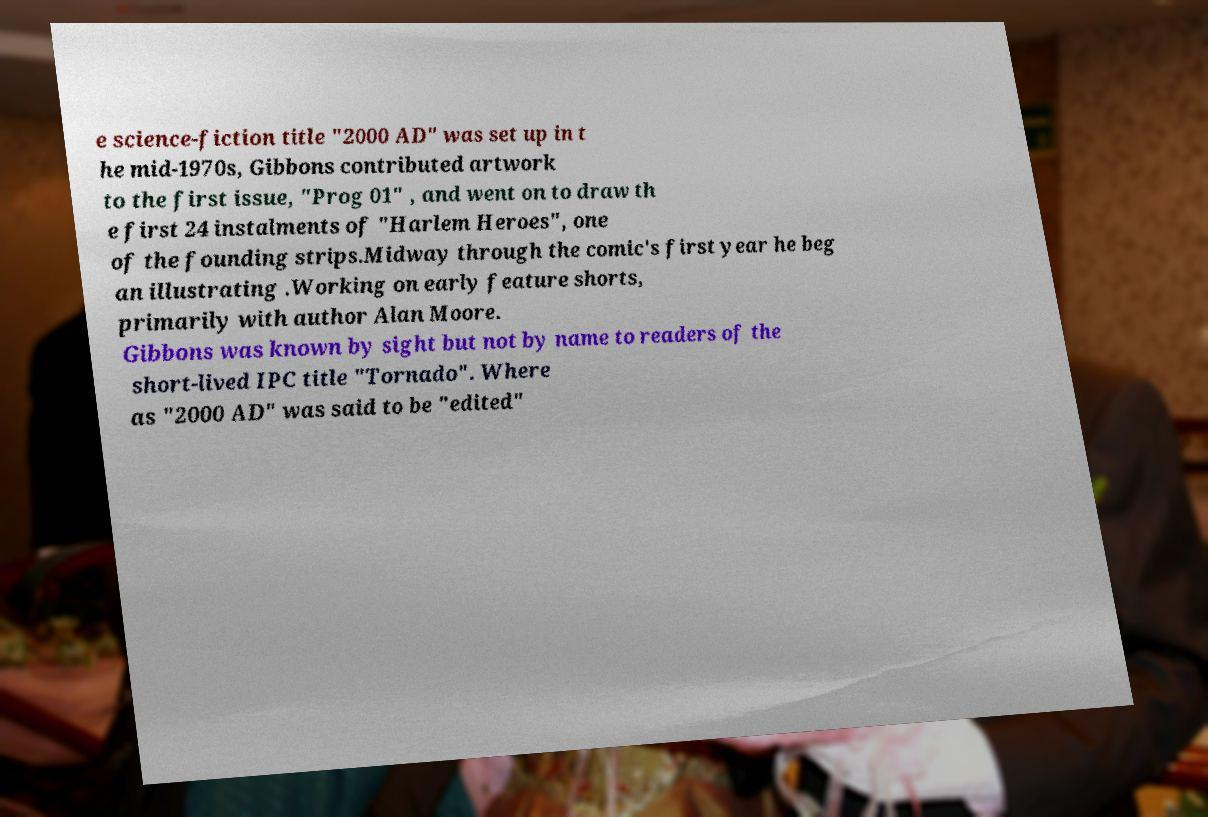Could you extract and type out the text from this image? e science-fiction title "2000 AD" was set up in t he mid-1970s, Gibbons contributed artwork to the first issue, "Prog 01" , and went on to draw th e first 24 instalments of "Harlem Heroes", one of the founding strips.Midway through the comic's first year he beg an illustrating .Working on early feature shorts, primarily with author Alan Moore. Gibbons was known by sight but not by name to readers of the short-lived IPC title "Tornado". Where as "2000 AD" was said to be "edited" 